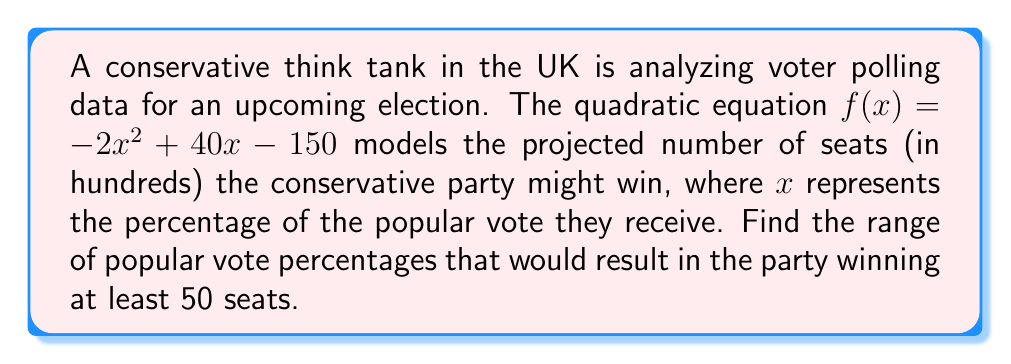Solve this math problem. To solve this problem, we need to follow these steps:

1) First, we need to set up an inequality to represent winning at least 50 seats:
   $f(x) \geq 50$ (remember, $f(x)$ is in hundreds of seats)
   $-2x^2 + 40x - 150 \geq 50$

2) Rearrange the inequality:
   $-2x^2 + 40x - 200 \geq 0$

3) To find the roots, we need to solve the equation:
   $-2x^2 + 40x - 200 = 0$

4) This is a quadratic equation in the form $ax^2 + bx + c = 0$, where:
   $a = -2$, $b = 40$, and $c = -200$

5) We can use the quadratic formula: $x = \frac{-b \pm \sqrt{b^2 - 4ac}}{2a}$

6) Substituting our values:
   $x = \frac{-40 \pm \sqrt{40^2 - 4(-2)(-200)}}{2(-2)}$
   $= \frac{-40 \pm \sqrt{1600 - 1600}}{-4}$
   $= \frac{-40 \pm 0}{-4}$
   $= 10$

7) This means there is only one solution, $x = 10$, which represents the turning point of the parabola.

8) Given that $a$ is negative, the parabola opens downward. This means the party wins at least 50 seats when $x$ is between the two points where the parabola intersects $y = 50$.

9) To find these points, we solve:
   $-2x^2 + 40x - 200 = 0$
   $(x - 5)(x - 20) = 0$
   $x = 5$ or $x = 20$

Therefore, the party wins at least 50 seats when the popular vote percentage is between 5% and 20%.
Answer: The conservative party will win at least 50 seats when their popular vote percentage is between 5% and 20%. 